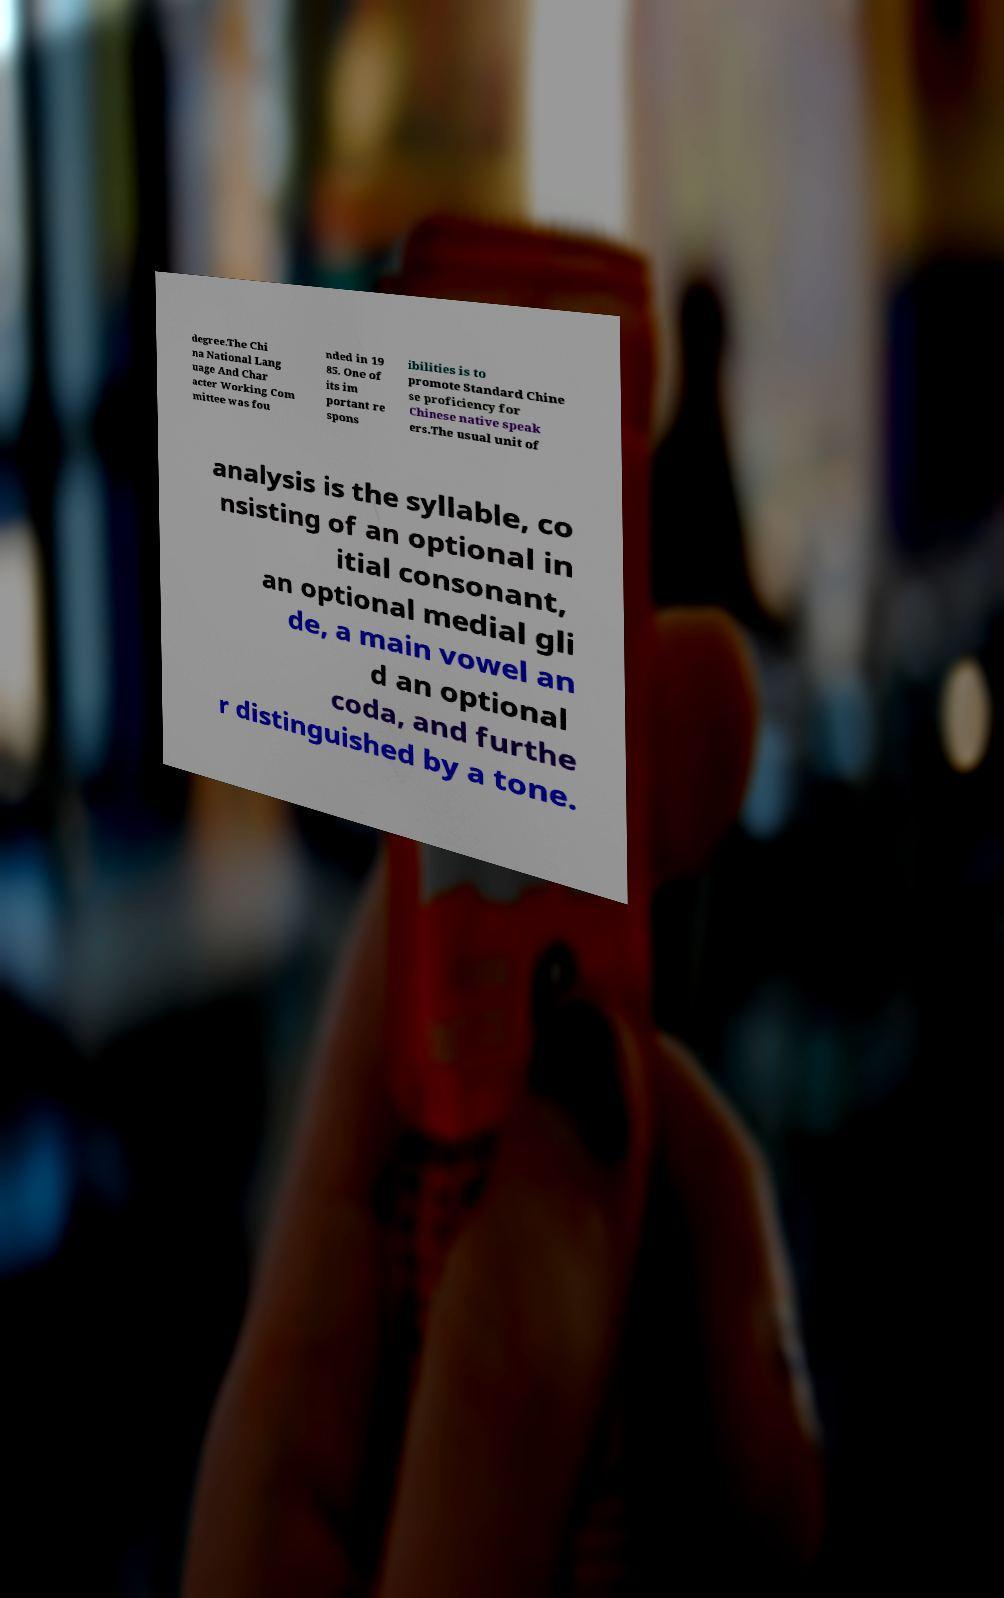For documentation purposes, I need the text within this image transcribed. Could you provide that? degree.The Chi na National Lang uage And Char acter Working Com mittee was fou nded in 19 85. One of its im portant re spons ibilities is to promote Standard Chine se proficiency for Chinese native speak ers.The usual unit of analysis is the syllable, co nsisting of an optional in itial consonant, an optional medial gli de, a main vowel an d an optional coda, and furthe r distinguished by a tone. 